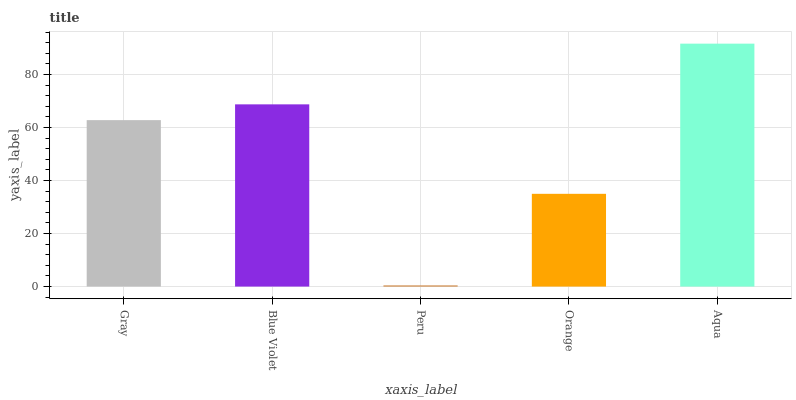Is Peru the minimum?
Answer yes or no. Yes. Is Aqua the maximum?
Answer yes or no. Yes. Is Blue Violet the minimum?
Answer yes or no. No. Is Blue Violet the maximum?
Answer yes or no. No. Is Blue Violet greater than Gray?
Answer yes or no. Yes. Is Gray less than Blue Violet?
Answer yes or no. Yes. Is Gray greater than Blue Violet?
Answer yes or no. No. Is Blue Violet less than Gray?
Answer yes or no. No. Is Gray the high median?
Answer yes or no. Yes. Is Gray the low median?
Answer yes or no. Yes. Is Aqua the high median?
Answer yes or no. No. Is Peru the low median?
Answer yes or no. No. 